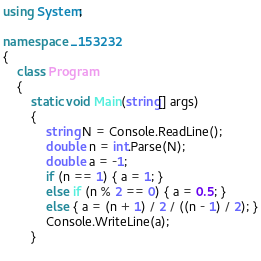<code> <loc_0><loc_0><loc_500><loc_500><_C#_>using System;

namespace _153232
{
    class Program
    {
        static void Main(string[] args)
        {
            string N = Console.ReadLine();
            double n = int.Parse(N);
            double a = -1;
            if (n == 1) { a = 1; }
            else if (n % 2 == 0) { a = 0.5; }
            else { a = (n + 1) / 2 / ((n - 1) / 2); }
            Console.WriteLine(a);
        }
  </code> 